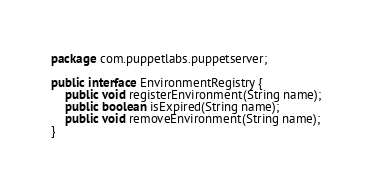Convert code to text. <code><loc_0><loc_0><loc_500><loc_500><_Java_>package com.puppetlabs.puppetserver;

public interface EnvironmentRegistry {
    public void registerEnvironment(String name);
    public boolean isExpired(String name);
    public void removeEnvironment(String name);
}
</code> 